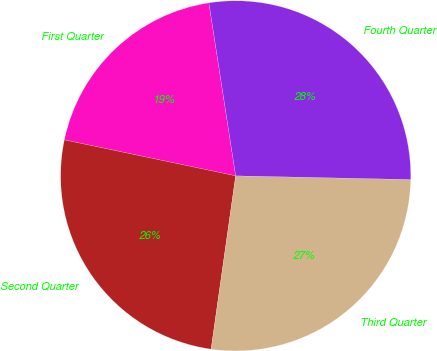Convert chart. <chart><loc_0><loc_0><loc_500><loc_500><pie_chart><fcel>First Quarter<fcel>Second Quarter<fcel>Third Quarter<fcel>Fourth Quarter<nl><fcel>19.26%<fcel>26.05%<fcel>26.9%<fcel>27.78%<nl></chart> 